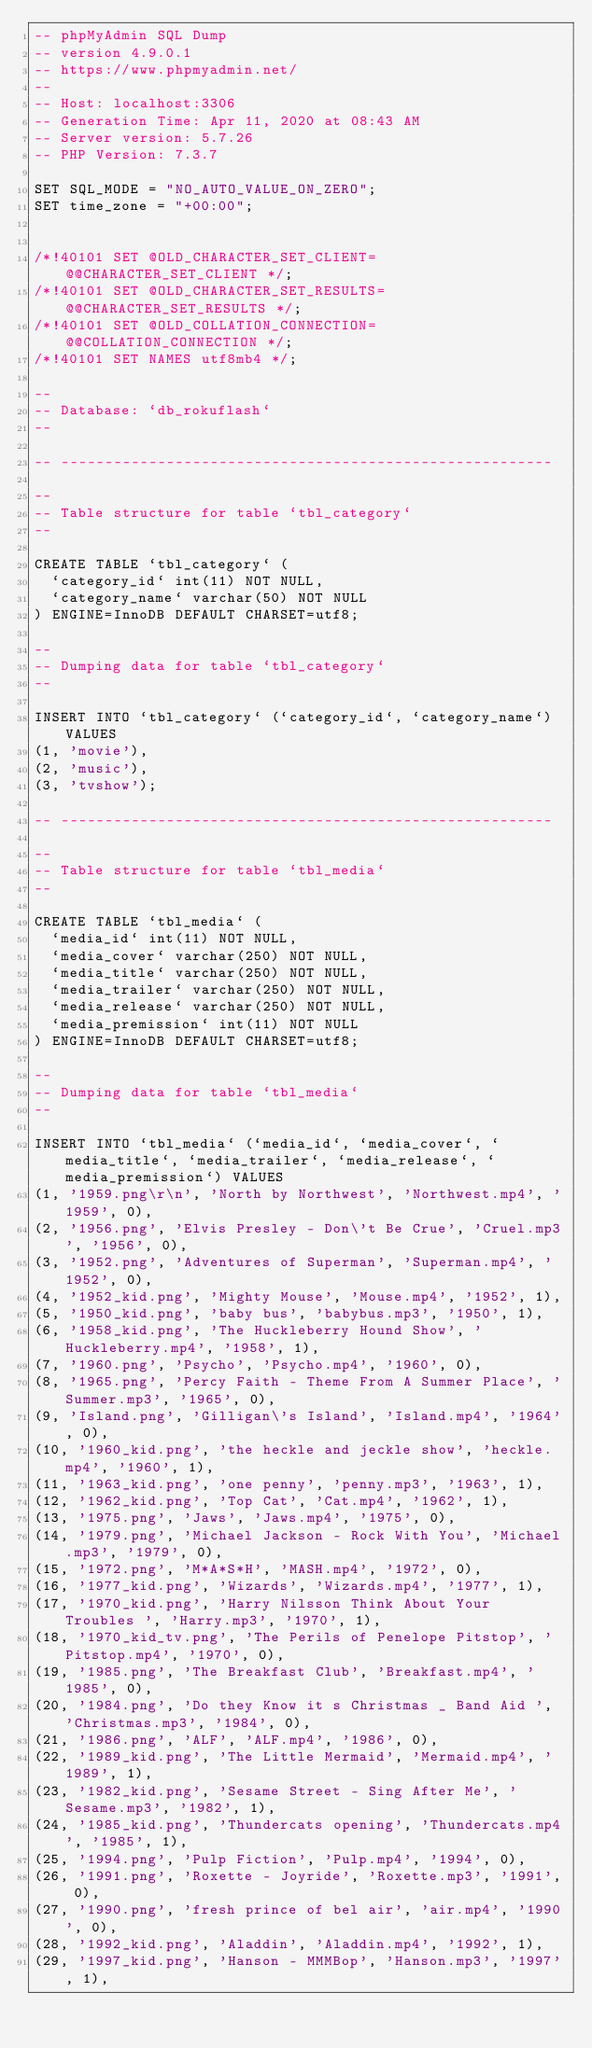Convert code to text. <code><loc_0><loc_0><loc_500><loc_500><_SQL_>-- phpMyAdmin SQL Dump
-- version 4.9.0.1
-- https://www.phpmyadmin.net/
--
-- Host: localhost:3306
-- Generation Time: Apr 11, 2020 at 08:43 AM
-- Server version: 5.7.26
-- PHP Version: 7.3.7

SET SQL_MODE = "NO_AUTO_VALUE_ON_ZERO";
SET time_zone = "+00:00";


/*!40101 SET @OLD_CHARACTER_SET_CLIENT=@@CHARACTER_SET_CLIENT */;
/*!40101 SET @OLD_CHARACTER_SET_RESULTS=@@CHARACTER_SET_RESULTS */;
/*!40101 SET @OLD_COLLATION_CONNECTION=@@COLLATION_CONNECTION */;
/*!40101 SET NAMES utf8mb4 */;

--
-- Database: `db_rokuflash`
--

-- --------------------------------------------------------

--
-- Table structure for table `tbl_category`
--

CREATE TABLE `tbl_category` (
  `category_id` int(11) NOT NULL,
  `category_name` varchar(50) NOT NULL
) ENGINE=InnoDB DEFAULT CHARSET=utf8;

--
-- Dumping data for table `tbl_category`
--

INSERT INTO `tbl_category` (`category_id`, `category_name`) VALUES
(1, 'movie'),
(2, 'music'),
(3, 'tvshow');

-- --------------------------------------------------------

--
-- Table structure for table `tbl_media`
--

CREATE TABLE `tbl_media` (
  `media_id` int(11) NOT NULL,
  `media_cover` varchar(250) NOT NULL,
  `media_title` varchar(250) NOT NULL,
  `media_trailer` varchar(250) NOT NULL,
  `media_release` varchar(250) NOT NULL,
  `media_premission` int(11) NOT NULL
) ENGINE=InnoDB DEFAULT CHARSET=utf8;

--
-- Dumping data for table `tbl_media`
--

INSERT INTO `tbl_media` (`media_id`, `media_cover`, `media_title`, `media_trailer`, `media_release`, `media_premission`) VALUES
(1, '1959.png\r\n', 'North by Northwest', 'Northwest.mp4', '1959', 0),
(2, '1956.png', 'Elvis Presley - Don\'t Be Crue', 'Cruel.mp3', '1956', 0),
(3, '1952.png', 'Adventures of Superman', 'Superman.mp4', '1952', 0),
(4, '1952_kid.png', 'Mighty Mouse', 'Mouse.mp4', '1952', 1),
(5, '1950_kid.png', 'baby bus', 'babybus.mp3', '1950', 1),
(6, '1958_kid.png', 'The Huckleberry Hound Show', 'Huckleberry.mp4', '1958', 1),
(7, '1960.png', 'Psycho', 'Psycho.mp4', '1960', 0),
(8, '1965.png', 'Percy Faith - Theme From A Summer Place', 'Summer.mp3', '1965', 0),
(9, 'Island.png', 'Gilligan\'s Island', 'Island.mp4', '1964', 0),
(10, '1960_kid.png', 'the heckle and jeckle show', 'heckle.mp4', '1960', 1),
(11, '1963_kid.png', 'one penny', 'penny.mp3', '1963', 1),
(12, '1962_kid.png', 'Top Cat', 'Cat.mp4', '1962', 1),
(13, '1975.png', 'Jaws', 'Jaws.mp4', '1975', 0),
(14, '1979.png', 'Michael Jackson - Rock With You', 'Michael.mp3', '1979', 0),
(15, '1972.png', 'M*A*S*H', 'MASH.mp4', '1972', 0),
(16, '1977_kid.png', 'Wizards', 'Wizards.mp4', '1977', 1),
(17, '1970_kid.png', 'Harry Nilsson Think About Your Troubles ', 'Harry.mp3', '1970', 1),
(18, '1970_kid_tv.png', 'The Perils of Penelope Pitstop', 'Pitstop.mp4', '1970', 0),
(19, '1985.png', 'The Breakfast Club', 'Breakfast.mp4', '1985', 0),
(20, '1984.png', 'Do they Know it s Christmas _ Band Aid ', 'Christmas.mp3', '1984', 0),
(21, '1986.png', 'ALF', 'ALF.mp4', '1986', 0),
(22, '1989_kid.png', 'The Little Mermaid', 'Mermaid.mp4', '1989', 1),
(23, '1982_kid.png', 'Sesame Street - Sing After Me', 'Sesame.mp3', '1982', 1),
(24, '1985_kid.png', 'Thundercats opening', 'Thundercats.mp4', '1985', 1),
(25, '1994.png', 'Pulp Fiction', 'Pulp.mp4', '1994', 0),
(26, '1991.png', 'Roxette - Joyride', 'Roxette.mp3', '1991', 0),
(27, '1990.png', 'fresh prince of bel air', 'air.mp4', '1990', 0),
(28, '1992_kid.png', 'Aladdin', 'Aladdin.mp4', '1992', 1),
(29, '1997_kid.png', 'Hanson - MMMBop', 'Hanson.mp3', '1997', 1),</code> 